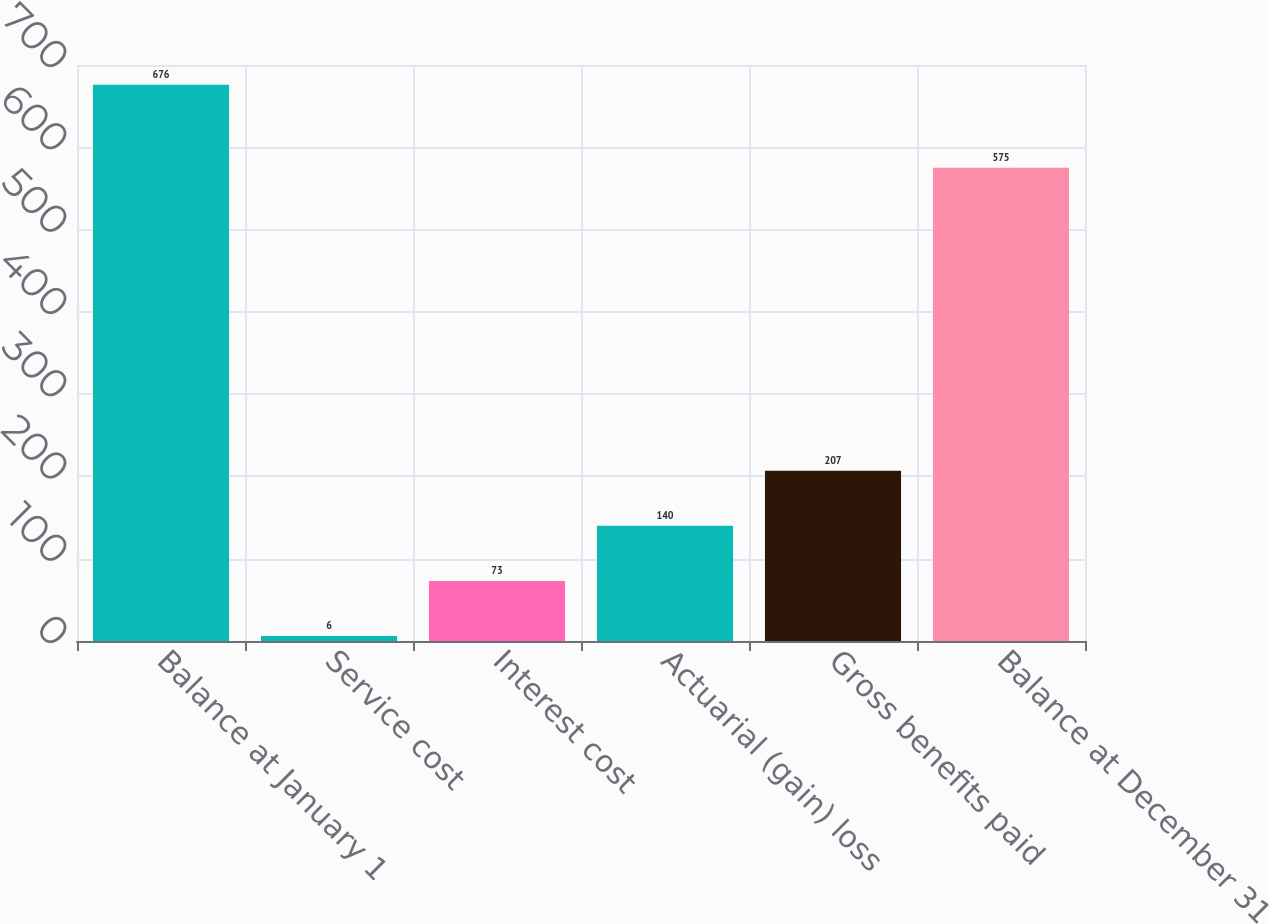Convert chart. <chart><loc_0><loc_0><loc_500><loc_500><bar_chart><fcel>Balance at January 1<fcel>Service cost<fcel>Interest cost<fcel>Actuarial (gain) loss<fcel>Gross benefits paid<fcel>Balance at December 31<nl><fcel>676<fcel>6<fcel>73<fcel>140<fcel>207<fcel>575<nl></chart> 